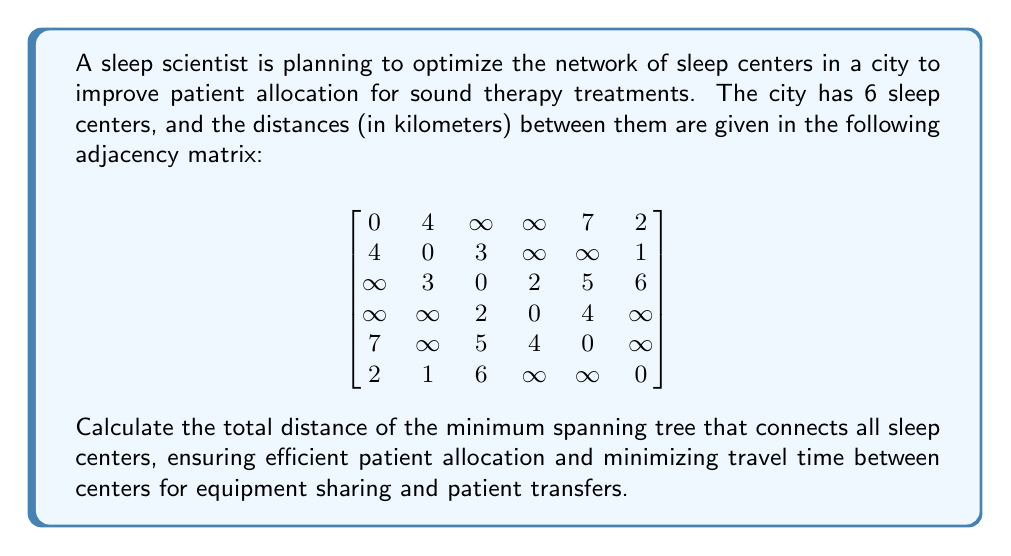What is the answer to this math problem? To find the minimum spanning tree (MST) of the sleep centers, we can use Kruskal's algorithm. This algorithm works by sorting all edges by weight (distance) and then adding edges to the MST, starting with the smallest, as long as they don't create a cycle.

Let's follow the steps:

1. Sort all edges by weight:
   (2,6): 1 km
   (1,6): 2 km
   (2,3): 3 km
   (1,2): 4 km
   (3,4): 2 km
   (4,5): 4 km
   (3,5): 5 km
   (1,5): 7 km

2. Start adding edges to the MST:
   - Add (2,6): 1 km
   - Add (1,6): 2 km
   - Add (3,4): 2 km
   - Add (2,3): 3 km
   - Add (4,5): 4 km

3. We now have all 6 vertices connected with 5 edges, forming the MST.

4. Calculate the total distance:
   $$1 + 2 + 2 + 3 + 4 = 12 \text{ km}$$

[asy]
import graph;

size(200);

void mark_edge(pair a, pair b, pen p = currentpen) {
  draw(a--b, p+1);
}

pair[] g = {
  (0,0), (2,1), (3,-1), (4,0), (2,-2), (1,1)
};

for (int i = 0; i < 6; ++i)
  dot(g[i]);

mark_edge(g[1], g[5], red);
mark_edge(g[0], g[5], red);
mark_edge(g[2], g[3], red);
mark_edge(g[1], g[2], red);
mark_edge(g[3], g[4], red);

label("1", g[0], SW);
label("2", g[1], N);
label("3", g[2], SE);
label("4", g[3], E);
label("5", g[4], S);
label("6", g[5], NW);

label("1km", (g[1]+g[5])/2, N);
label("2km", (g[0]+g[5])/2, NW);
label("2km", (g[2]+g[3])/2, NE);
label("3km", (g[1]+g[2])/2, E);
label("4km", (g[3]+g[4])/2, SE);
[/asy]

The diagram above shows the minimum spanning tree connecting all sleep centers. The red lines represent the edges in the MST, with their corresponding distances labeled.
Answer: The total distance of the minimum spanning tree connecting all sleep centers is 12 km. 